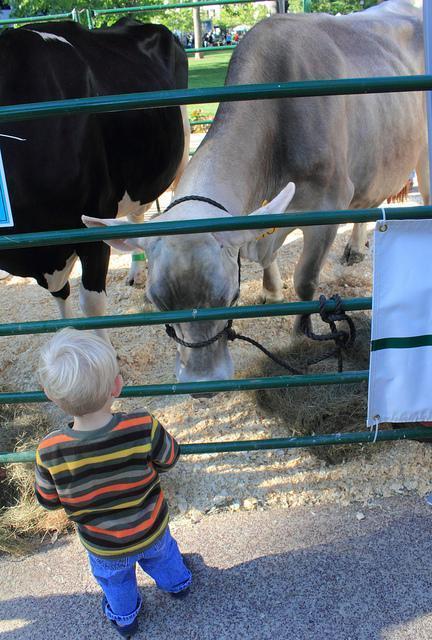How many cows can you see?
Give a very brief answer. 2. 